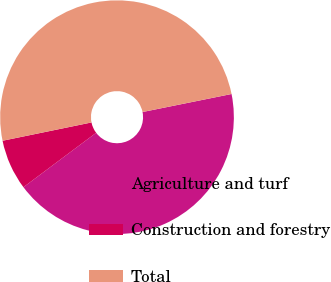<chart> <loc_0><loc_0><loc_500><loc_500><pie_chart><fcel>Agriculture and turf<fcel>Construction and forestry<fcel>Total<nl><fcel>42.96%<fcel>6.99%<fcel>50.05%<nl></chart> 